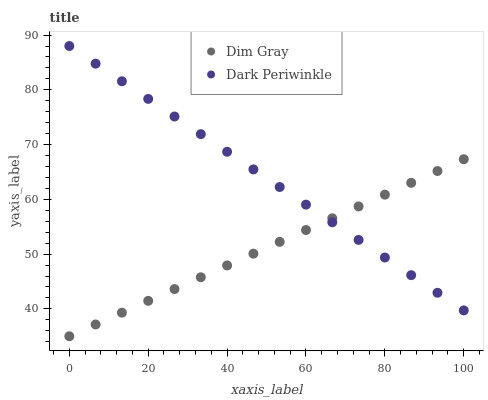Does Dim Gray have the minimum area under the curve?
Answer yes or no. Yes. Does Dark Periwinkle have the maximum area under the curve?
Answer yes or no. Yes. Does Dark Periwinkle have the minimum area under the curve?
Answer yes or no. No. Is Dim Gray the smoothest?
Answer yes or no. Yes. Is Dark Periwinkle the roughest?
Answer yes or no. Yes. Is Dark Periwinkle the smoothest?
Answer yes or no. No. Does Dim Gray have the lowest value?
Answer yes or no. Yes. Does Dark Periwinkle have the lowest value?
Answer yes or no. No. Does Dark Periwinkle have the highest value?
Answer yes or no. Yes. Does Dim Gray intersect Dark Periwinkle?
Answer yes or no. Yes. Is Dim Gray less than Dark Periwinkle?
Answer yes or no. No. Is Dim Gray greater than Dark Periwinkle?
Answer yes or no. No. 